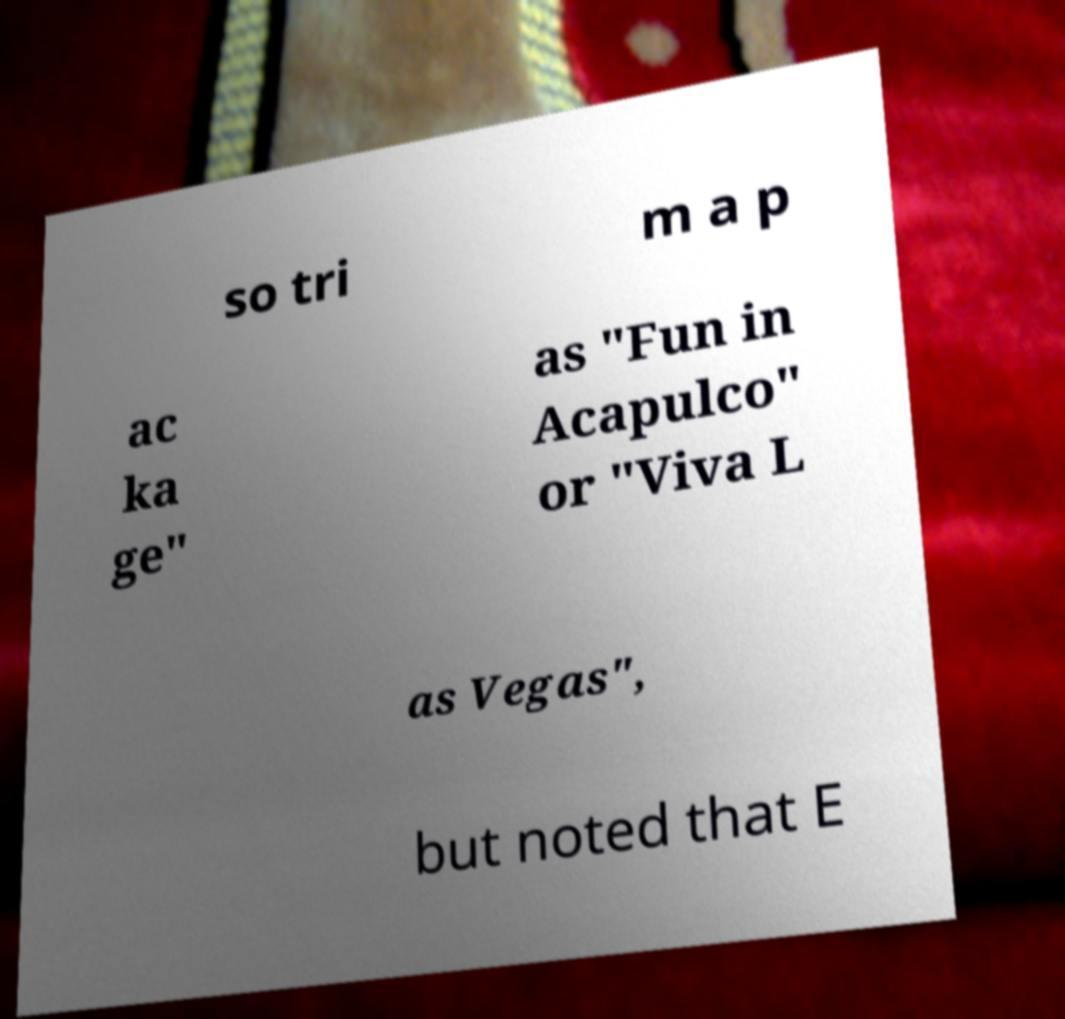I need the written content from this picture converted into text. Can you do that? so tri m a p ac ka ge" as "Fun in Acapulco" or "Viva L as Vegas", but noted that E 